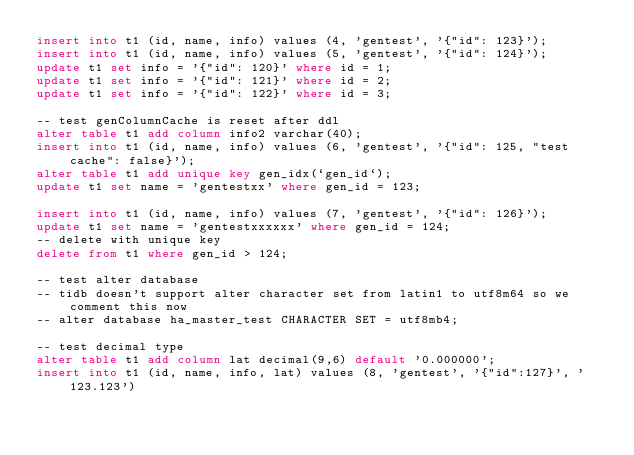Convert code to text. <code><loc_0><loc_0><loc_500><loc_500><_SQL_>insert into t1 (id, name, info) values (4, 'gentest', '{"id": 123}');
insert into t1 (id, name, info) values (5, 'gentest', '{"id": 124}');
update t1 set info = '{"id": 120}' where id = 1;
update t1 set info = '{"id": 121}' where id = 2;
update t1 set info = '{"id": 122}' where id = 3;

-- test genColumnCache is reset after ddl
alter table t1 add column info2 varchar(40);
insert into t1 (id, name, info) values (6, 'gentest', '{"id": 125, "test cache": false}');
alter table t1 add unique key gen_idx(`gen_id`);
update t1 set name = 'gentestxx' where gen_id = 123;

insert into t1 (id, name, info) values (7, 'gentest', '{"id": 126}');
update t1 set name = 'gentestxxxxxx' where gen_id = 124;
-- delete with unique key
delete from t1 where gen_id > 124;

-- test alter database
-- tidb doesn't support alter character set from latin1 to utf8m64 so we comment this now
-- alter database ha_master_test CHARACTER SET = utf8mb4;

-- test decimal type
alter table t1 add column lat decimal(9,6) default '0.000000';
insert into t1 (id, name, info, lat) values (8, 'gentest', '{"id":127}', '123.123')
</code> 